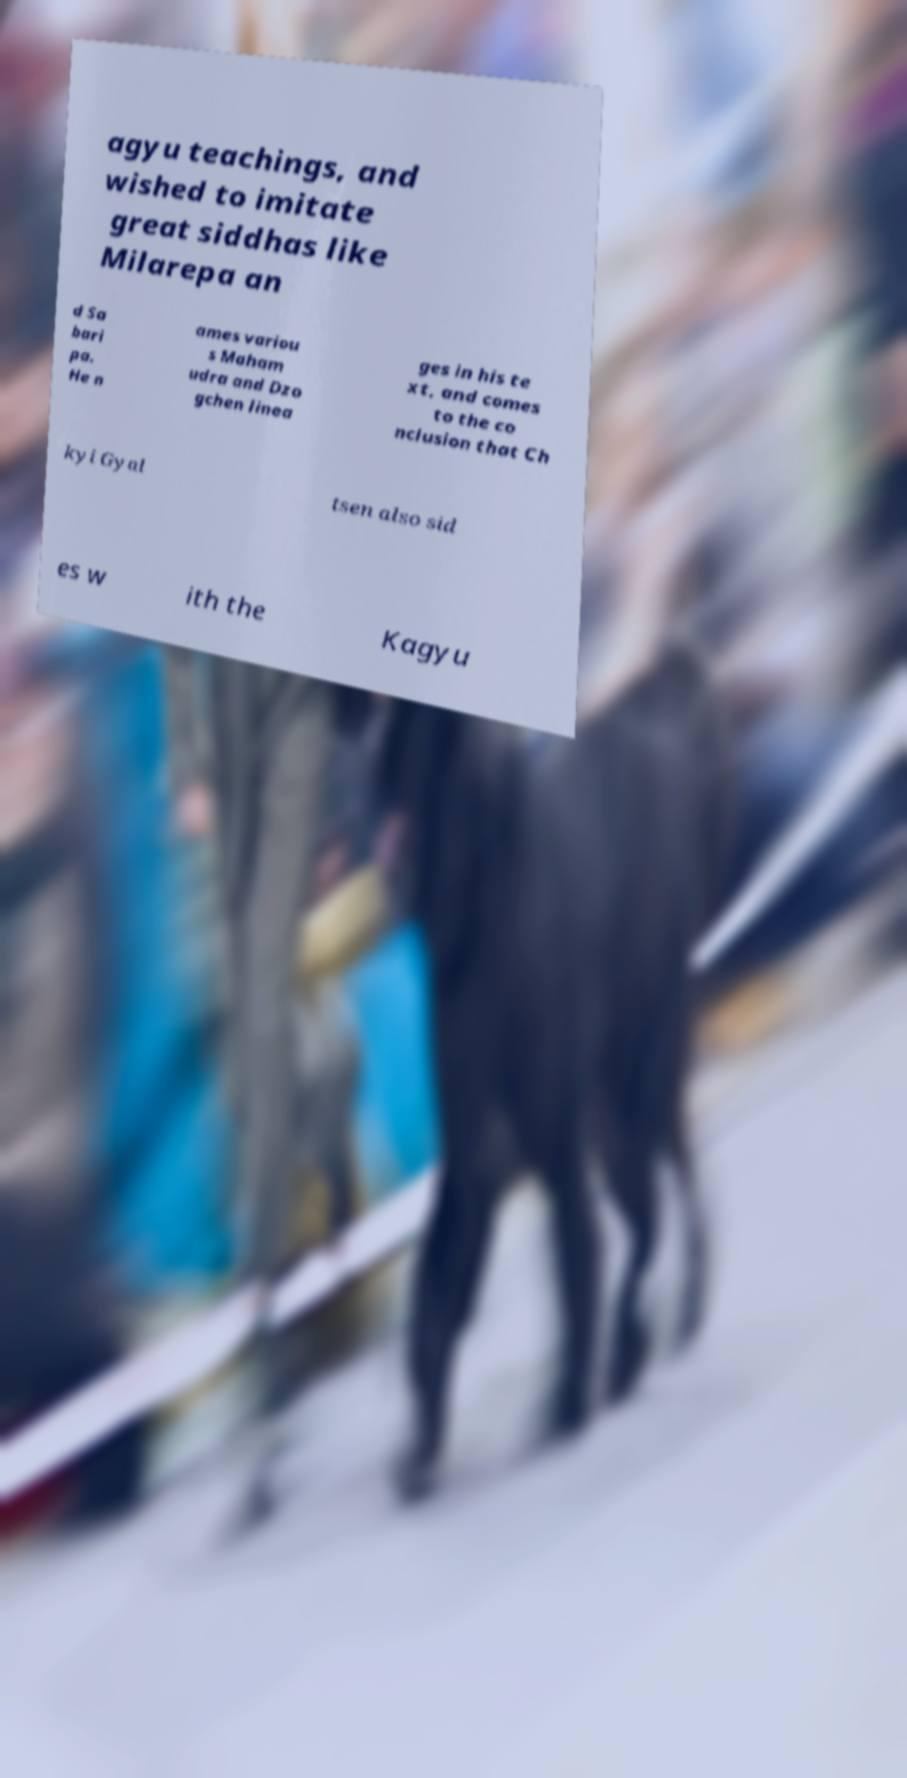Could you assist in decoding the text presented in this image and type it out clearly? agyu teachings, and wished to imitate great siddhas like Milarepa an d Sa bari pa. He n ames variou s Maham udra and Dzo gchen linea ges in his te xt, and comes to the co nclusion that Ch kyi Gyal tsen also sid es w ith the Kagyu 